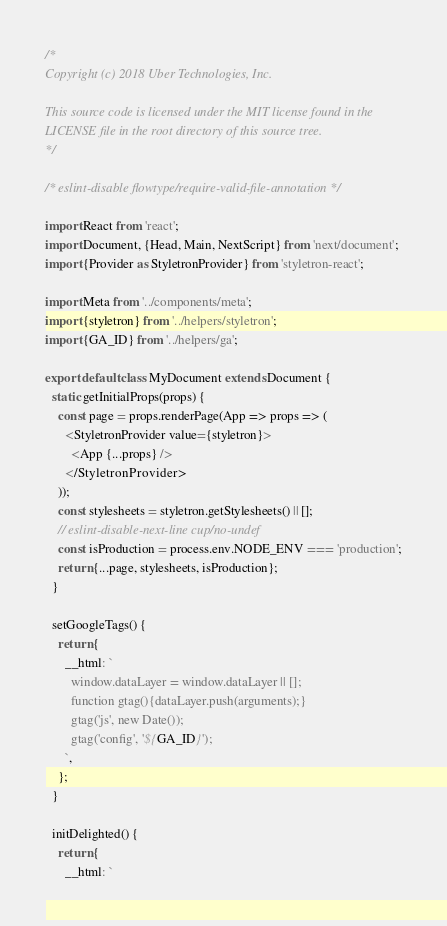<code> <loc_0><loc_0><loc_500><loc_500><_JavaScript_>/*
Copyright (c) 2018 Uber Technologies, Inc.

This source code is licensed under the MIT license found in the
LICENSE file in the root directory of this source tree.
*/

/* eslint-disable flowtype/require-valid-file-annotation */

import React from 'react';
import Document, {Head, Main, NextScript} from 'next/document';
import {Provider as StyletronProvider} from 'styletron-react';

import Meta from '../components/meta';
import {styletron} from '../helpers/styletron';
import {GA_ID} from '../helpers/ga';

export default class MyDocument extends Document {
  static getInitialProps(props) {
    const page = props.renderPage(App => props => (
      <StyletronProvider value={styletron}>
        <App {...props} />
      </StyletronProvider>
    ));
    const stylesheets = styletron.getStylesheets() || [];
    // eslint-disable-next-line cup/no-undef
    const isProduction = process.env.NODE_ENV === 'production';
    return {...page, stylesheets, isProduction};
  }

  setGoogleTags() {
    return {
      __html: `
        window.dataLayer = window.dataLayer || [];
        function gtag(){dataLayer.push(arguments);}
        gtag('js', new Date());
        gtag('config', '${GA_ID}');
      `,
    };
  }

  initDelighted() {
    return {
      __html: `</code> 